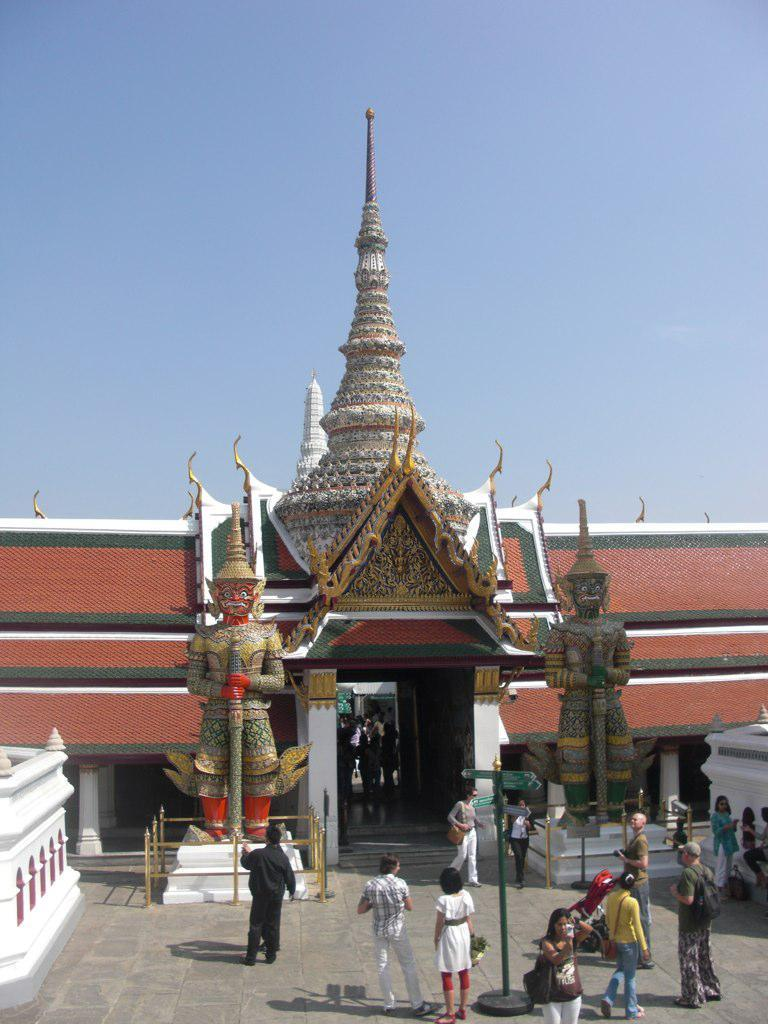What type of structure is visible in the image? There is a building in the image. What decorative elements can be seen in the image? There are statues in the image. What is attached to a pole in the image? There is a sign board on a pole in the image. Can you describe the people in the image? There is a group of people in the image. What type of material is used for the poles in the image? The poles in the image are made of metal. How would you describe the weather in the image? The sky is visible in the image, and it appears cloudy. What type of statement can be seen on the bone in the image? There is no bone present in the image, and therefore no statement can be seen on it. 